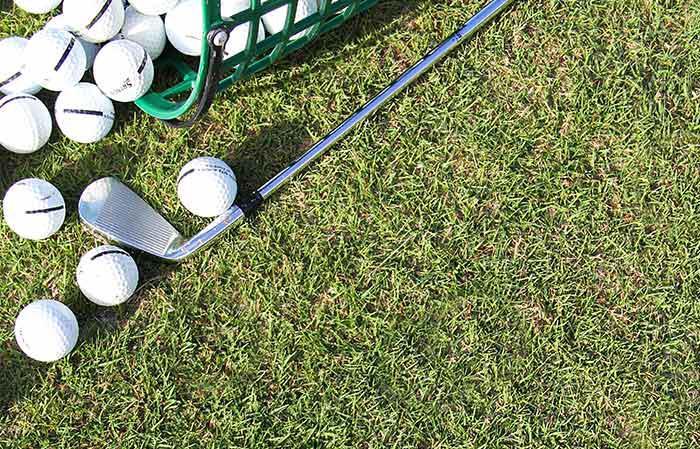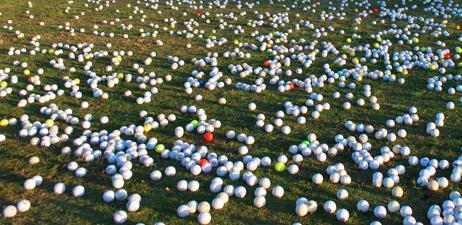The first image is the image on the left, the second image is the image on the right. Examine the images to the left and right. Is the description "In one photo, a green bucket of golf balls is laying on its side in grass with no golf clubs visible" accurate? Answer yes or no. No. The first image is the image on the left, the second image is the image on the right. For the images displayed, is the sentence "A golf club is next to at least one golf ball in one image." factually correct? Answer yes or no. Yes. 